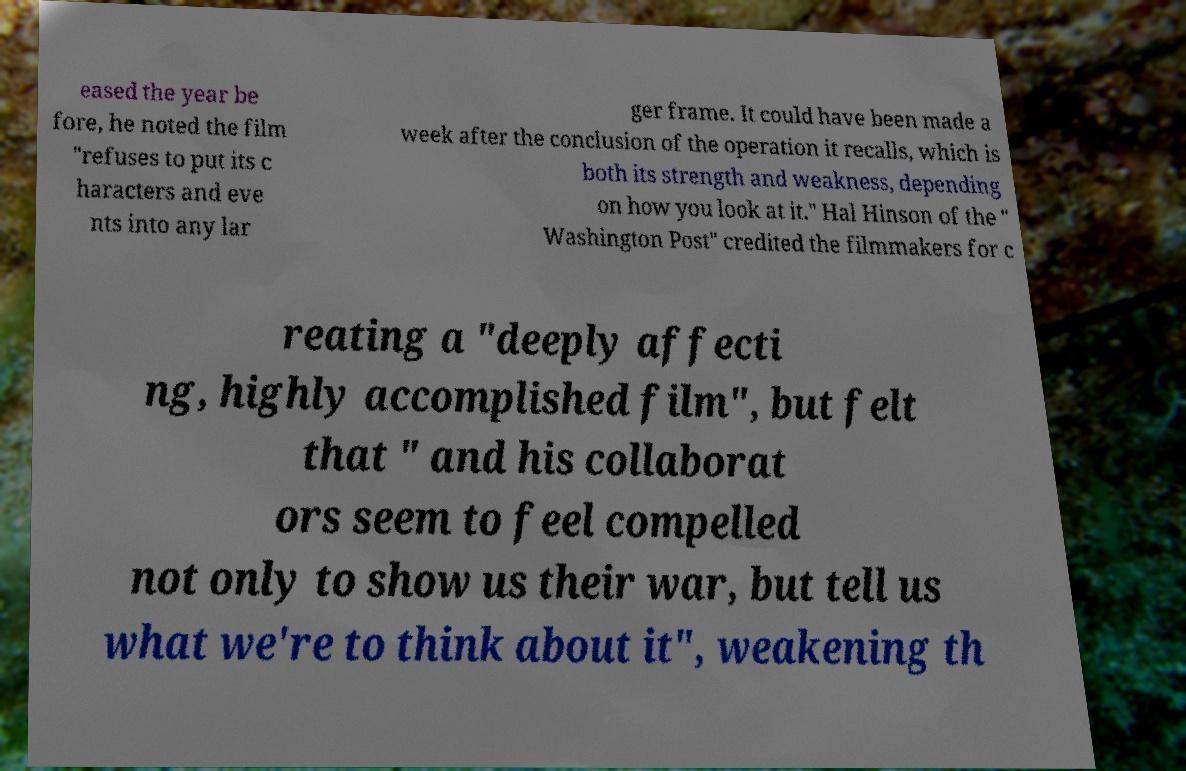I need the written content from this picture converted into text. Can you do that? eased the year be fore, he noted the film "refuses to put its c haracters and eve nts into any lar ger frame. It could have been made a week after the conclusion of the operation it recalls, which is both its strength and weakness, depending on how you look at it." Hal Hinson of the " Washington Post" credited the filmmakers for c reating a "deeply affecti ng, highly accomplished film", but felt that " and his collaborat ors seem to feel compelled not only to show us their war, but tell us what we're to think about it", weakening th 